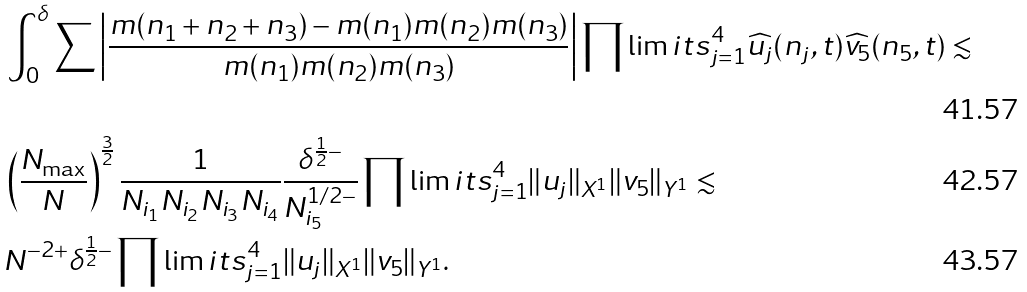Convert formula to latex. <formula><loc_0><loc_0><loc_500><loc_500>& \int _ { 0 } ^ { \delta } \sum \left | \frac { m ( n _ { 1 } + n _ { 2 } + n _ { 3 } ) - m ( n _ { 1 } ) m ( n _ { 2 } ) m ( n _ { 3 } ) } { m ( n _ { 1 } ) m ( n _ { 2 } ) m ( n _ { 3 } ) } \right | \prod \lim i t s _ { j = 1 } ^ { 4 } \widehat { u _ { j } } ( n _ { j } , t ) \widehat { v _ { 5 } } ( n _ { 5 } , t ) \lesssim \\ & \left ( \frac { N _ { \max } } { N } \right ) ^ { \frac { 3 } { 2 } } \frac { 1 } { N _ { i _ { 1 } } N _ { i _ { 2 } } N _ { i _ { 3 } } N _ { i _ { 4 } } } \frac { \delta ^ { \frac { 1 } { 2 } - } } { N _ { i _ { 5 } } ^ { 1 / 2 - } } \prod \lim i t s _ { j = 1 } ^ { 4 } \| u _ { j } \| _ { X ^ { 1 } } \| v _ { 5 } \| _ { Y ^ { 1 } } \lesssim \\ & N ^ { - 2 + } \delta ^ { \frac { 1 } { 2 } - } \prod \lim i t s _ { j = 1 } ^ { 4 } \| u _ { j } \| _ { X ^ { 1 } } \| v _ { 5 } \| _ { Y ^ { 1 } } .</formula> 